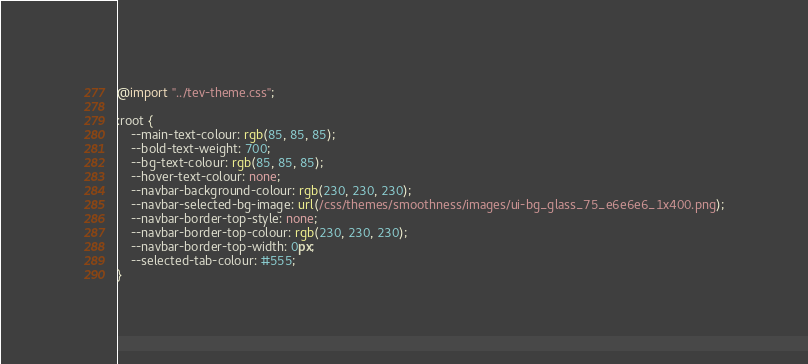<code> <loc_0><loc_0><loc_500><loc_500><_CSS_>@import "../tev-theme.css";

:root {
	--main-text-colour: rgb(85, 85, 85);
	--bold-text-weight: 700;
	--bg-text-colour: rgb(85, 85, 85);
	--hover-text-colour: none;
	--navbar-background-colour: rgb(230, 230, 230);
	--navbar-selected-bg-image: url(/css/themes/smoothness/images/ui-bg_glass_75_e6e6e6_1x400.png);
	--navbar-border-top-style: none;
	--navbar-border-top-colour: rgb(230, 230, 230);
	--navbar-border-top-width: 0px;
	--selected-tab-colour: #555;
}
</code> 